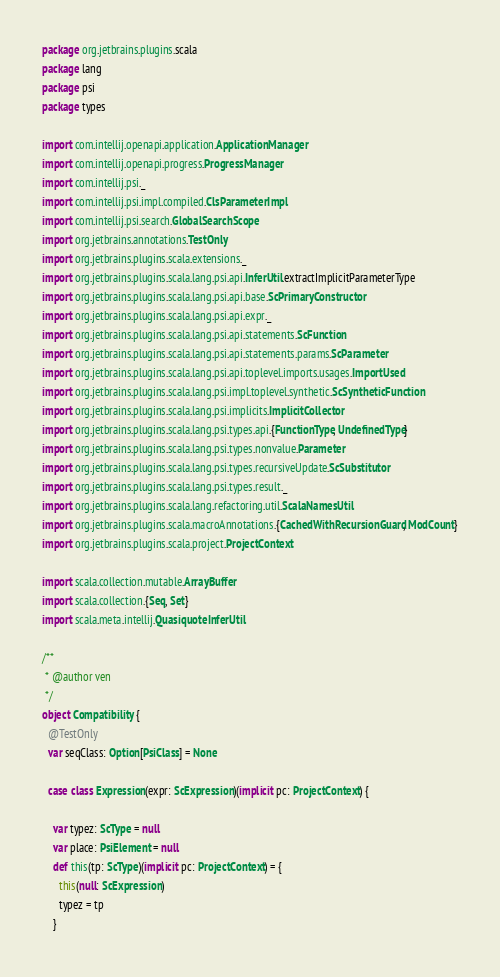<code> <loc_0><loc_0><loc_500><loc_500><_Scala_>package org.jetbrains.plugins.scala
package lang
package psi
package types

import com.intellij.openapi.application.ApplicationManager
import com.intellij.openapi.progress.ProgressManager
import com.intellij.psi._
import com.intellij.psi.impl.compiled.ClsParameterImpl
import com.intellij.psi.search.GlobalSearchScope
import org.jetbrains.annotations.TestOnly
import org.jetbrains.plugins.scala.extensions._
import org.jetbrains.plugins.scala.lang.psi.api.InferUtil.extractImplicitParameterType
import org.jetbrains.plugins.scala.lang.psi.api.base.ScPrimaryConstructor
import org.jetbrains.plugins.scala.lang.psi.api.expr._
import org.jetbrains.plugins.scala.lang.psi.api.statements.ScFunction
import org.jetbrains.plugins.scala.lang.psi.api.statements.params.ScParameter
import org.jetbrains.plugins.scala.lang.psi.api.toplevel.imports.usages.ImportUsed
import org.jetbrains.plugins.scala.lang.psi.impl.toplevel.synthetic.ScSyntheticFunction
import org.jetbrains.plugins.scala.lang.psi.implicits.ImplicitCollector
import org.jetbrains.plugins.scala.lang.psi.types.api.{FunctionType, UndefinedType}
import org.jetbrains.plugins.scala.lang.psi.types.nonvalue.Parameter
import org.jetbrains.plugins.scala.lang.psi.types.recursiveUpdate.ScSubstitutor
import org.jetbrains.plugins.scala.lang.psi.types.result._
import org.jetbrains.plugins.scala.lang.refactoring.util.ScalaNamesUtil
import org.jetbrains.plugins.scala.macroAnnotations.{CachedWithRecursionGuard, ModCount}
import org.jetbrains.plugins.scala.project.ProjectContext

import scala.collection.mutable.ArrayBuffer
import scala.collection.{Seq, Set}
import scala.meta.intellij.QuasiquoteInferUtil

/**
 * @author ven
 */
object Compatibility {
  @TestOnly
  var seqClass: Option[PsiClass] = None

  case class Expression(expr: ScExpression)(implicit pc: ProjectContext) {

    var typez: ScType = null
    var place: PsiElement = null
    def this(tp: ScType)(implicit pc: ProjectContext) = {
      this(null: ScExpression)
      typez = tp
    }</code> 